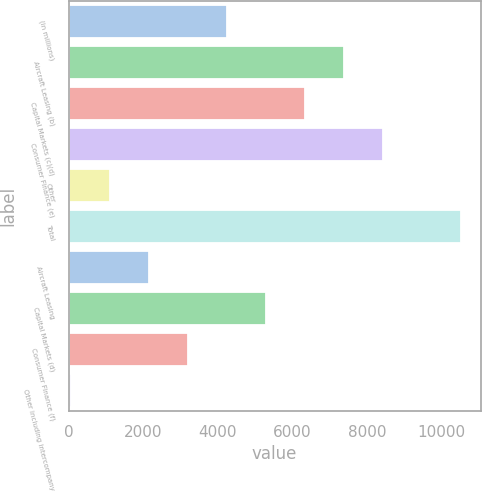<chart> <loc_0><loc_0><loc_500><loc_500><bar_chart><fcel>(in millions)<fcel>Aircraft Leasing (b)<fcel>Capital Markets (c)(d)<fcel>Consumer Finance (e)<fcel>Other<fcel>Total<fcel>Aircraft Leasing<fcel>Capital Markets (d)<fcel>Consumer Finance (f)<fcel>Other including intercompany<nl><fcel>4246<fcel>7385.5<fcel>6339<fcel>8432<fcel>1106.5<fcel>10525<fcel>2153<fcel>5292.5<fcel>3199.5<fcel>60<nl></chart> 